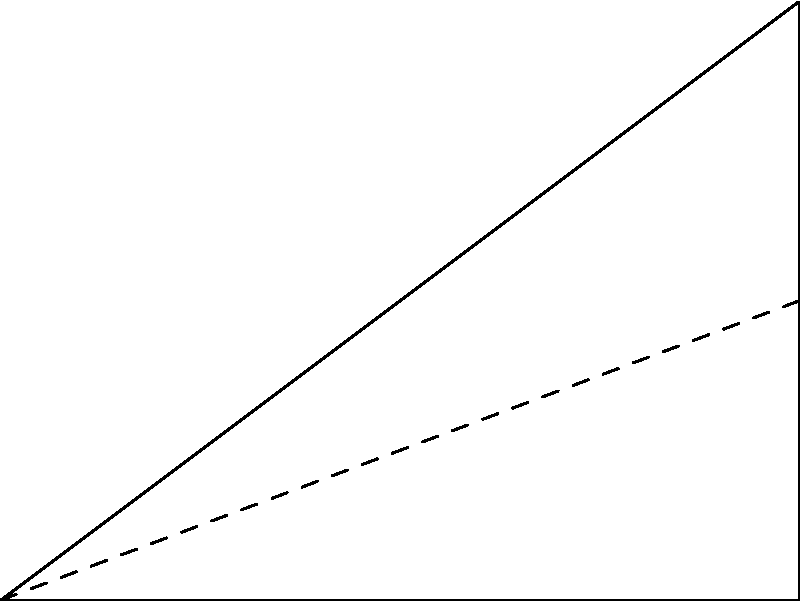In pattern making, what is the optimal angle for cutting fabric to minimize waste when creating a right-angled triangular piece? To determine the optimal angle for cutting fabric to minimize waste, we need to consider the properties of right-angled triangles and the principles of fabric utilization:

1. In a right-angled triangle, one angle is always 90°.
2. The sum of angles in a triangle is always 180°.
3. To minimize waste, we want to maximize the area of the triangle while using the least amount of fabric.
4. The largest possible area for a right-angled triangle occurs when it is isosceles, i.e., when the two non-right angles are equal.

Let's calculate the optimal angle:

1. Let $x$ be one of the non-right angles.
2. The other non-right angle will also be $x$ (for an isosceles right-angled triangle).
3. We know that the sum of angles in a triangle is 180°:
   $90^\circ + x + x = 180^\circ$
4. Simplifying:
   $90^\circ + 2x = 180^\circ$
   $2x = 90^\circ$
   $x = 45^\circ$

Therefore, the optimal angle for cutting fabric to create a right-angled triangular piece with minimal waste is 45°. This creates an isosceles right-angled triangle, also known as a 45-45-90 triangle.

By cutting at a 45° angle, you maximize the area of the triangle relative to the amount of fabric used, thus minimizing waste in the pattern-making process.
Answer: 45° 